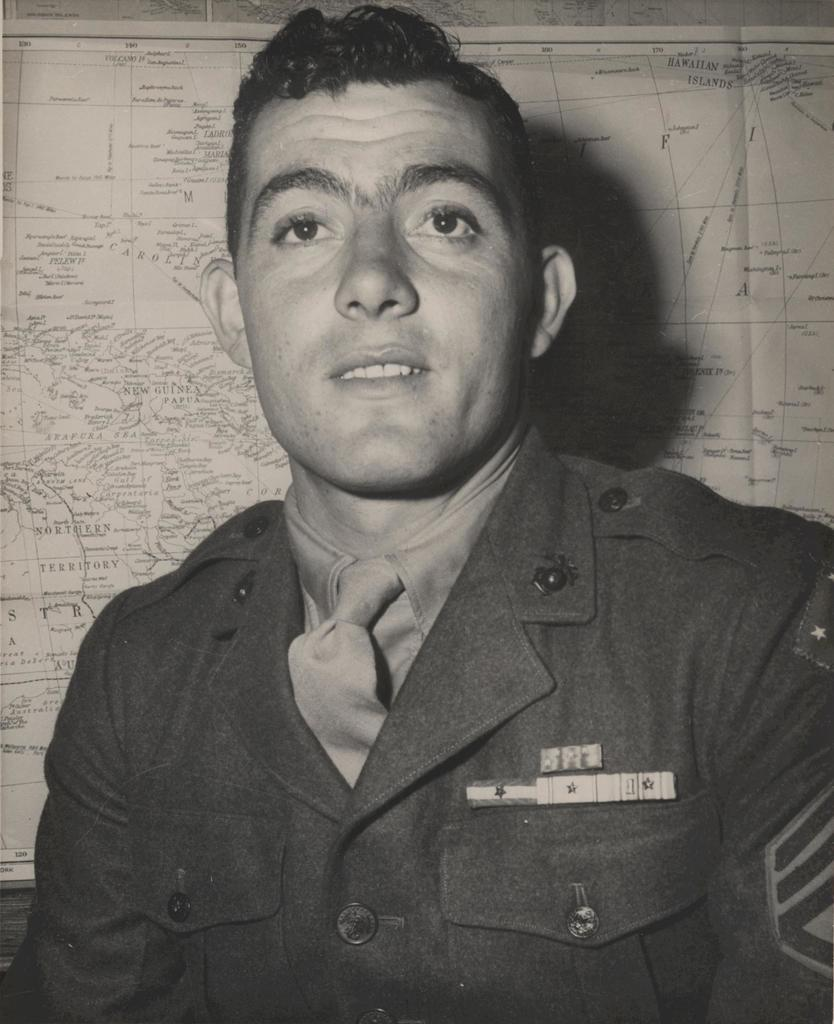What is present in the image? There is a person in the image. Can you describe the person's appearance? The person is wearing clothes. What can be seen in the background of the image? There is a map in the background of the image. How many friends are visible in the image? There is no friend present in the image; only a person and a map are visible. What type of field can be seen in the image? There is no field present in the image; it features a person, clothes, and a map. 